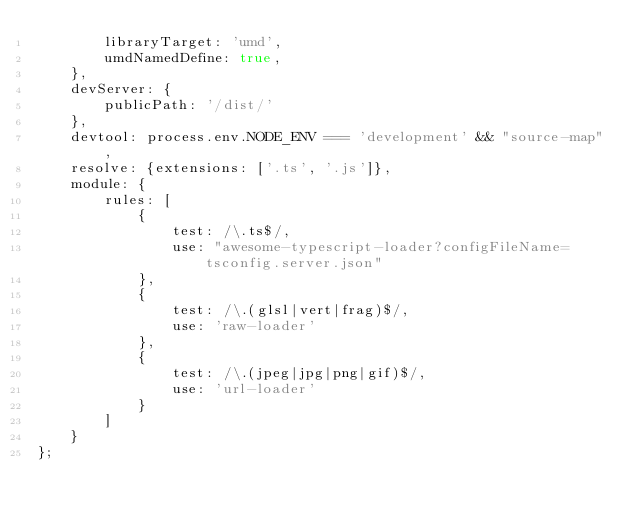<code> <loc_0><loc_0><loc_500><loc_500><_JavaScript_>        libraryTarget: 'umd',
        umdNamedDefine: true,
    },
    devServer: {
        publicPath: '/dist/'
    },
    devtool: process.env.NODE_ENV === 'development' && "source-map",
    resolve: {extensions: ['.ts', '.js']},
    module: {
        rules: [ 
            { 
                test: /\.ts$/, 
                use: "awesome-typescript-loader?configFileName=tsconfig.server.json"
            },
            {
                test: /\.(glsl|vert|frag)$/,
                use: 'raw-loader'
            }, 
            {
                test: /\.(jpeg|jpg|png|gif)$/,
                use: 'url-loader'
            } 
        ]
    }
};
</code> 